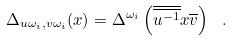Convert formula to latex. <formula><loc_0><loc_0><loc_500><loc_500>\Delta _ { u \omega _ { i } , v \omega _ { i } } ( x ) = \Delta ^ { \omega _ { i } } \left ( \overline { \overline { u ^ { - 1 } } } x \overline { v } \right ) \ .</formula> 